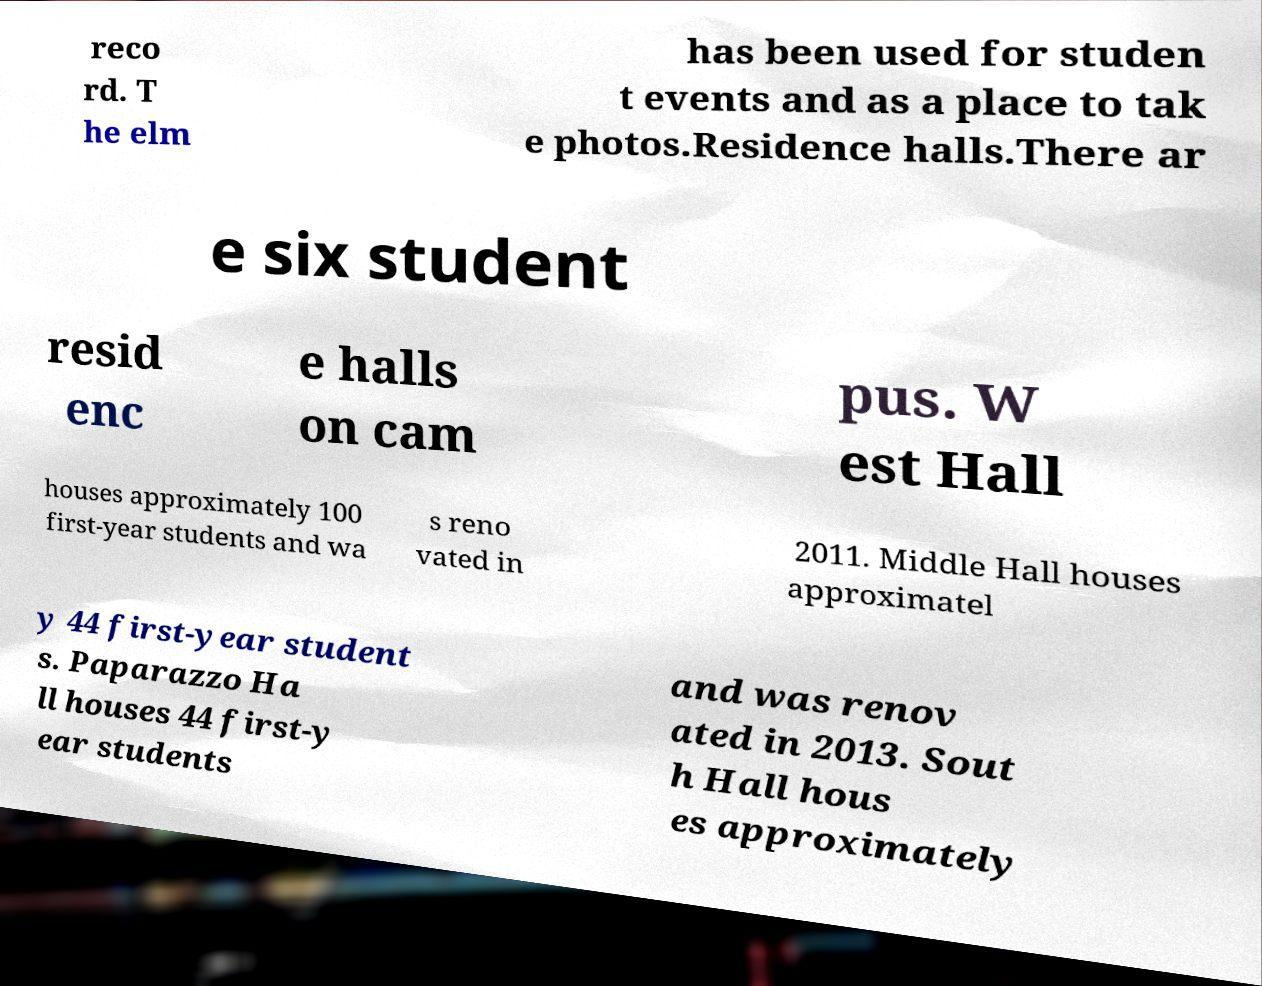I need the written content from this picture converted into text. Can you do that? reco rd. T he elm has been used for studen t events and as a place to tak e photos.Residence halls.There ar e six student resid enc e halls on cam pus. W est Hall houses approximately 100 first-year students and wa s reno vated in 2011. Middle Hall houses approximatel y 44 first-year student s. Paparazzo Ha ll houses 44 first-y ear students and was renov ated in 2013. Sout h Hall hous es approximately 